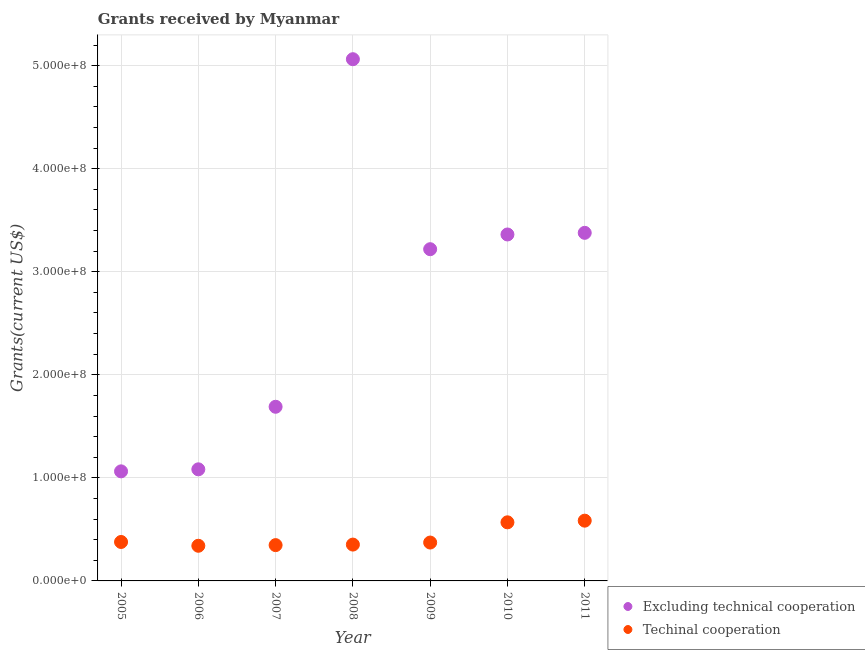How many different coloured dotlines are there?
Provide a succinct answer. 2. Is the number of dotlines equal to the number of legend labels?
Provide a succinct answer. Yes. What is the amount of grants received(including technical cooperation) in 2009?
Make the answer very short. 3.72e+07. Across all years, what is the maximum amount of grants received(including technical cooperation)?
Provide a succinct answer. 5.85e+07. Across all years, what is the minimum amount of grants received(including technical cooperation)?
Give a very brief answer. 3.41e+07. In which year was the amount of grants received(excluding technical cooperation) maximum?
Ensure brevity in your answer.  2008. What is the total amount of grants received(including technical cooperation) in the graph?
Ensure brevity in your answer.  2.94e+08. What is the difference between the amount of grants received(excluding technical cooperation) in 2009 and that in 2011?
Make the answer very short. -1.59e+07. What is the difference between the amount of grants received(including technical cooperation) in 2006 and the amount of grants received(excluding technical cooperation) in 2005?
Make the answer very short. -7.22e+07. What is the average amount of grants received(including technical cooperation) per year?
Offer a very short reply. 4.21e+07. In the year 2010, what is the difference between the amount of grants received(excluding technical cooperation) and amount of grants received(including technical cooperation)?
Give a very brief answer. 2.79e+08. In how many years, is the amount of grants received(including technical cooperation) greater than 160000000 US$?
Keep it short and to the point. 0. What is the ratio of the amount of grants received(excluding technical cooperation) in 2005 to that in 2006?
Your answer should be compact. 0.98. What is the difference between the highest and the second highest amount of grants received(excluding technical cooperation)?
Keep it short and to the point. 1.68e+08. What is the difference between the highest and the lowest amount of grants received(excluding technical cooperation)?
Offer a terse response. 4.00e+08. Is the sum of the amount of grants received(including technical cooperation) in 2010 and 2011 greater than the maximum amount of grants received(excluding technical cooperation) across all years?
Give a very brief answer. No. Does the amount of grants received(including technical cooperation) monotonically increase over the years?
Provide a short and direct response. No. Is the amount of grants received(excluding technical cooperation) strictly greater than the amount of grants received(including technical cooperation) over the years?
Keep it short and to the point. Yes. Is the amount of grants received(including technical cooperation) strictly less than the amount of grants received(excluding technical cooperation) over the years?
Your answer should be compact. Yes. How many dotlines are there?
Ensure brevity in your answer.  2. How many years are there in the graph?
Provide a succinct answer. 7. What is the difference between two consecutive major ticks on the Y-axis?
Make the answer very short. 1.00e+08. Does the graph contain any zero values?
Your answer should be compact. No. Does the graph contain grids?
Offer a very short reply. Yes. Where does the legend appear in the graph?
Provide a succinct answer. Bottom right. What is the title of the graph?
Your answer should be very brief. Grants received by Myanmar. Does "Non-resident workers" appear as one of the legend labels in the graph?
Your answer should be compact. No. What is the label or title of the X-axis?
Your answer should be compact. Year. What is the label or title of the Y-axis?
Provide a short and direct response. Grants(current US$). What is the Grants(current US$) in Excluding technical cooperation in 2005?
Make the answer very short. 1.06e+08. What is the Grants(current US$) in Techinal cooperation in 2005?
Your answer should be compact. 3.78e+07. What is the Grants(current US$) of Excluding technical cooperation in 2006?
Ensure brevity in your answer.  1.08e+08. What is the Grants(current US$) in Techinal cooperation in 2006?
Give a very brief answer. 3.41e+07. What is the Grants(current US$) in Excluding technical cooperation in 2007?
Your answer should be compact. 1.69e+08. What is the Grants(current US$) in Techinal cooperation in 2007?
Ensure brevity in your answer.  3.47e+07. What is the Grants(current US$) of Excluding technical cooperation in 2008?
Keep it short and to the point. 5.06e+08. What is the Grants(current US$) of Techinal cooperation in 2008?
Offer a terse response. 3.53e+07. What is the Grants(current US$) in Excluding technical cooperation in 2009?
Provide a short and direct response. 3.22e+08. What is the Grants(current US$) of Techinal cooperation in 2009?
Give a very brief answer. 3.72e+07. What is the Grants(current US$) of Excluding technical cooperation in 2010?
Offer a very short reply. 3.36e+08. What is the Grants(current US$) of Techinal cooperation in 2010?
Offer a very short reply. 5.69e+07. What is the Grants(current US$) in Excluding technical cooperation in 2011?
Your response must be concise. 3.38e+08. What is the Grants(current US$) of Techinal cooperation in 2011?
Your answer should be compact. 5.85e+07. Across all years, what is the maximum Grants(current US$) in Excluding technical cooperation?
Your response must be concise. 5.06e+08. Across all years, what is the maximum Grants(current US$) of Techinal cooperation?
Provide a short and direct response. 5.85e+07. Across all years, what is the minimum Grants(current US$) of Excluding technical cooperation?
Your response must be concise. 1.06e+08. Across all years, what is the minimum Grants(current US$) of Techinal cooperation?
Offer a very short reply. 3.41e+07. What is the total Grants(current US$) of Excluding technical cooperation in the graph?
Offer a terse response. 1.89e+09. What is the total Grants(current US$) of Techinal cooperation in the graph?
Offer a terse response. 2.94e+08. What is the difference between the Grants(current US$) in Excluding technical cooperation in 2005 and that in 2006?
Your response must be concise. -1.97e+06. What is the difference between the Grants(current US$) of Techinal cooperation in 2005 and that in 2006?
Your answer should be very brief. 3.68e+06. What is the difference between the Grants(current US$) in Excluding technical cooperation in 2005 and that in 2007?
Your response must be concise. -6.27e+07. What is the difference between the Grants(current US$) of Techinal cooperation in 2005 and that in 2007?
Provide a succinct answer. 3.05e+06. What is the difference between the Grants(current US$) in Excluding technical cooperation in 2005 and that in 2008?
Give a very brief answer. -4.00e+08. What is the difference between the Grants(current US$) of Techinal cooperation in 2005 and that in 2008?
Provide a succinct answer. 2.53e+06. What is the difference between the Grants(current US$) in Excluding technical cooperation in 2005 and that in 2009?
Your answer should be very brief. -2.16e+08. What is the difference between the Grants(current US$) in Excluding technical cooperation in 2005 and that in 2010?
Offer a terse response. -2.30e+08. What is the difference between the Grants(current US$) of Techinal cooperation in 2005 and that in 2010?
Your response must be concise. -1.91e+07. What is the difference between the Grants(current US$) of Excluding technical cooperation in 2005 and that in 2011?
Your answer should be compact. -2.31e+08. What is the difference between the Grants(current US$) in Techinal cooperation in 2005 and that in 2011?
Give a very brief answer. -2.07e+07. What is the difference between the Grants(current US$) in Excluding technical cooperation in 2006 and that in 2007?
Make the answer very short. -6.07e+07. What is the difference between the Grants(current US$) of Techinal cooperation in 2006 and that in 2007?
Provide a short and direct response. -6.30e+05. What is the difference between the Grants(current US$) in Excluding technical cooperation in 2006 and that in 2008?
Your answer should be compact. -3.98e+08. What is the difference between the Grants(current US$) of Techinal cooperation in 2006 and that in 2008?
Provide a short and direct response. -1.15e+06. What is the difference between the Grants(current US$) in Excluding technical cooperation in 2006 and that in 2009?
Your response must be concise. -2.14e+08. What is the difference between the Grants(current US$) of Techinal cooperation in 2006 and that in 2009?
Your answer should be very brief. -3.13e+06. What is the difference between the Grants(current US$) of Excluding technical cooperation in 2006 and that in 2010?
Provide a succinct answer. -2.28e+08. What is the difference between the Grants(current US$) of Techinal cooperation in 2006 and that in 2010?
Offer a very short reply. -2.28e+07. What is the difference between the Grants(current US$) of Excluding technical cooperation in 2006 and that in 2011?
Ensure brevity in your answer.  -2.29e+08. What is the difference between the Grants(current US$) in Techinal cooperation in 2006 and that in 2011?
Provide a succinct answer. -2.44e+07. What is the difference between the Grants(current US$) of Excluding technical cooperation in 2007 and that in 2008?
Offer a terse response. -3.37e+08. What is the difference between the Grants(current US$) of Techinal cooperation in 2007 and that in 2008?
Offer a very short reply. -5.20e+05. What is the difference between the Grants(current US$) in Excluding technical cooperation in 2007 and that in 2009?
Provide a short and direct response. -1.53e+08. What is the difference between the Grants(current US$) of Techinal cooperation in 2007 and that in 2009?
Provide a short and direct response. -2.50e+06. What is the difference between the Grants(current US$) in Excluding technical cooperation in 2007 and that in 2010?
Ensure brevity in your answer.  -1.67e+08. What is the difference between the Grants(current US$) in Techinal cooperation in 2007 and that in 2010?
Your answer should be very brief. -2.21e+07. What is the difference between the Grants(current US$) of Excluding technical cooperation in 2007 and that in 2011?
Your response must be concise. -1.69e+08. What is the difference between the Grants(current US$) of Techinal cooperation in 2007 and that in 2011?
Your response must be concise. -2.37e+07. What is the difference between the Grants(current US$) of Excluding technical cooperation in 2008 and that in 2009?
Offer a terse response. 1.84e+08. What is the difference between the Grants(current US$) of Techinal cooperation in 2008 and that in 2009?
Provide a succinct answer. -1.98e+06. What is the difference between the Grants(current US$) of Excluding technical cooperation in 2008 and that in 2010?
Offer a terse response. 1.70e+08. What is the difference between the Grants(current US$) in Techinal cooperation in 2008 and that in 2010?
Your answer should be compact. -2.16e+07. What is the difference between the Grants(current US$) of Excluding technical cooperation in 2008 and that in 2011?
Give a very brief answer. 1.68e+08. What is the difference between the Grants(current US$) of Techinal cooperation in 2008 and that in 2011?
Ensure brevity in your answer.  -2.32e+07. What is the difference between the Grants(current US$) in Excluding technical cooperation in 2009 and that in 2010?
Keep it short and to the point. -1.43e+07. What is the difference between the Grants(current US$) in Techinal cooperation in 2009 and that in 2010?
Ensure brevity in your answer.  -1.96e+07. What is the difference between the Grants(current US$) of Excluding technical cooperation in 2009 and that in 2011?
Give a very brief answer. -1.59e+07. What is the difference between the Grants(current US$) in Techinal cooperation in 2009 and that in 2011?
Your answer should be very brief. -2.12e+07. What is the difference between the Grants(current US$) in Excluding technical cooperation in 2010 and that in 2011?
Give a very brief answer. -1.59e+06. What is the difference between the Grants(current US$) in Techinal cooperation in 2010 and that in 2011?
Give a very brief answer. -1.61e+06. What is the difference between the Grants(current US$) of Excluding technical cooperation in 2005 and the Grants(current US$) of Techinal cooperation in 2006?
Your response must be concise. 7.22e+07. What is the difference between the Grants(current US$) of Excluding technical cooperation in 2005 and the Grants(current US$) of Techinal cooperation in 2007?
Ensure brevity in your answer.  7.16e+07. What is the difference between the Grants(current US$) in Excluding technical cooperation in 2005 and the Grants(current US$) in Techinal cooperation in 2008?
Ensure brevity in your answer.  7.11e+07. What is the difference between the Grants(current US$) of Excluding technical cooperation in 2005 and the Grants(current US$) of Techinal cooperation in 2009?
Offer a very short reply. 6.91e+07. What is the difference between the Grants(current US$) in Excluding technical cooperation in 2005 and the Grants(current US$) in Techinal cooperation in 2010?
Your answer should be very brief. 4.95e+07. What is the difference between the Grants(current US$) of Excluding technical cooperation in 2005 and the Grants(current US$) of Techinal cooperation in 2011?
Give a very brief answer. 4.78e+07. What is the difference between the Grants(current US$) in Excluding technical cooperation in 2006 and the Grants(current US$) in Techinal cooperation in 2007?
Give a very brief answer. 7.36e+07. What is the difference between the Grants(current US$) of Excluding technical cooperation in 2006 and the Grants(current US$) of Techinal cooperation in 2008?
Give a very brief answer. 7.30e+07. What is the difference between the Grants(current US$) of Excluding technical cooperation in 2006 and the Grants(current US$) of Techinal cooperation in 2009?
Give a very brief answer. 7.10e+07. What is the difference between the Grants(current US$) in Excluding technical cooperation in 2006 and the Grants(current US$) in Techinal cooperation in 2010?
Provide a succinct answer. 5.14e+07. What is the difference between the Grants(current US$) in Excluding technical cooperation in 2006 and the Grants(current US$) in Techinal cooperation in 2011?
Offer a terse response. 4.98e+07. What is the difference between the Grants(current US$) in Excluding technical cooperation in 2007 and the Grants(current US$) in Techinal cooperation in 2008?
Keep it short and to the point. 1.34e+08. What is the difference between the Grants(current US$) of Excluding technical cooperation in 2007 and the Grants(current US$) of Techinal cooperation in 2009?
Provide a succinct answer. 1.32e+08. What is the difference between the Grants(current US$) in Excluding technical cooperation in 2007 and the Grants(current US$) in Techinal cooperation in 2010?
Your answer should be very brief. 1.12e+08. What is the difference between the Grants(current US$) of Excluding technical cooperation in 2007 and the Grants(current US$) of Techinal cooperation in 2011?
Your answer should be very brief. 1.11e+08. What is the difference between the Grants(current US$) in Excluding technical cooperation in 2008 and the Grants(current US$) in Techinal cooperation in 2009?
Ensure brevity in your answer.  4.69e+08. What is the difference between the Grants(current US$) in Excluding technical cooperation in 2008 and the Grants(current US$) in Techinal cooperation in 2010?
Give a very brief answer. 4.49e+08. What is the difference between the Grants(current US$) of Excluding technical cooperation in 2008 and the Grants(current US$) of Techinal cooperation in 2011?
Keep it short and to the point. 4.48e+08. What is the difference between the Grants(current US$) in Excluding technical cooperation in 2009 and the Grants(current US$) in Techinal cooperation in 2010?
Your answer should be very brief. 2.65e+08. What is the difference between the Grants(current US$) of Excluding technical cooperation in 2009 and the Grants(current US$) of Techinal cooperation in 2011?
Your answer should be compact. 2.63e+08. What is the difference between the Grants(current US$) in Excluding technical cooperation in 2010 and the Grants(current US$) in Techinal cooperation in 2011?
Your response must be concise. 2.78e+08. What is the average Grants(current US$) in Excluding technical cooperation per year?
Provide a succinct answer. 2.69e+08. What is the average Grants(current US$) in Techinal cooperation per year?
Provide a short and direct response. 4.21e+07. In the year 2005, what is the difference between the Grants(current US$) of Excluding technical cooperation and Grants(current US$) of Techinal cooperation?
Provide a succinct answer. 6.85e+07. In the year 2006, what is the difference between the Grants(current US$) in Excluding technical cooperation and Grants(current US$) in Techinal cooperation?
Provide a short and direct response. 7.42e+07. In the year 2007, what is the difference between the Grants(current US$) of Excluding technical cooperation and Grants(current US$) of Techinal cooperation?
Your answer should be very brief. 1.34e+08. In the year 2008, what is the difference between the Grants(current US$) in Excluding technical cooperation and Grants(current US$) in Techinal cooperation?
Ensure brevity in your answer.  4.71e+08. In the year 2009, what is the difference between the Grants(current US$) of Excluding technical cooperation and Grants(current US$) of Techinal cooperation?
Ensure brevity in your answer.  2.85e+08. In the year 2010, what is the difference between the Grants(current US$) in Excluding technical cooperation and Grants(current US$) in Techinal cooperation?
Make the answer very short. 2.79e+08. In the year 2011, what is the difference between the Grants(current US$) of Excluding technical cooperation and Grants(current US$) of Techinal cooperation?
Offer a very short reply. 2.79e+08. What is the ratio of the Grants(current US$) in Excluding technical cooperation in 2005 to that in 2006?
Your response must be concise. 0.98. What is the ratio of the Grants(current US$) in Techinal cooperation in 2005 to that in 2006?
Keep it short and to the point. 1.11. What is the ratio of the Grants(current US$) in Excluding technical cooperation in 2005 to that in 2007?
Offer a very short reply. 0.63. What is the ratio of the Grants(current US$) of Techinal cooperation in 2005 to that in 2007?
Ensure brevity in your answer.  1.09. What is the ratio of the Grants(current US$) of Excluding technical cooperation in 2005 to that in 2008?
Offer a very short reply. 0.21. What is the ratio of the Grants(current US$) of Techinal cooperation in 2005 to that in 2008?
Offer a terse response. 1.07. What is the ratio of the Grants(current US$) in Excluding technical cooperation in 2005 to that in 2009?
Your answer should be very brief. 0.33. What is the ratio of the Grants(current US$) of Techinal cooperation in 2005 to that in 2009?
Offer a very short reply. 1.01. What is the ratio of the Grants(current US$) of Excluding technical cooperation in 2005 to that in 2010?
Make the answer very short. 0.32. What is the ratio of the Grants(current US$) in Techinal cooperation in 2005 to that in 2010?
Make the answer very short. 0.66. What is the ratio of the Grants(current US$) of Excluding technical cooperation in 2005 to that in 2011?
Make the answer very short. 0.31. What is the ratio of the Grants(current US$) in Techinal cooperation in 2005 to that in 2011?
Your response must be concise. 0.65. What is the ratio of the Grants(current US$) of Excluding technical cooperation in 2006 to that in 2007?
Give a very brief answer. 0.64. What is the ratio of the Grants(current US$) in Techinal cooperation in 2006 to that in 2007?
Offer a terse response. 0.98. What is the ratio of the Grants(current US$) of Excluding technical cooperation in 2006 to that in 2008?
Your answer should be very brief. 0.21. What is the ratio of the Grants(current US$) in Techinal cooperation in 2006 to that in 2008?
Your answer should be compact. 0.97. What is the ratio of the Grants(current US$) in Excluding technical cooperation in 2006 to that in 2009?
Your answer should be compact. 0.34. What is the ratio of the Grants(current US$) of Techinal cooperation in 2006 to that in 2009?
Ensure brevity in your answer.  0.92. What is the ratio of the Grants(current US$) in Excluding technical cooperation in 2006 to that in 2010?
Make the answer very short. 0.32. What is the ratio of the Grants(current US$) of Techinal cooperation in 2006 to that in 2010?
Your response must be concise. 0.6. What is the ratio of the Grants(current US$) of Excluding technical cooperation in 2006 to that in 2011?
Offer a terse response. 0.32. What is the ratio of the Grants(current US$) of Techinal cooperation in 2006 to that in 2011?
Your answer should be compact. 0.58. What is the ratio of the Grants(current US$) in Excluding technical cooperation in 2007 to that in 2008?
Keep it short and to the point. 0.33. What is the ratio of the Grants(current US$) of Excluding technical cooperation in 2007 to that in 2009?
Keep it short and to the point. 0.53. What is the ratio of the Grants(current US$) in Techinal cooperation in 2007 to that in 2009?
Ensure brevity in your answer.  0.93. What is the ratio of the Grants(current US$) of Excluding technical cooperation in 2007 to that in 2010?
Your response must be concise. 0.5. What is the ratio of the Grants(current US$) of Techinal cooperation in 2007 to that in 2010?
Your answer should be very brief. 0.61. What is the ratio of the Grants(current US$) of Excluding technical cooperation in 2007 to that in 2011?
Your answer should be compact. 0.5. What is the ratio of the Grants(current US$) in Techinal cooperation in 2007 to that in 2011?
Your answer should be compact. 0.59. What is the ratio of the Grants(current US$) in Excluding technical cooperation in 2008 to that in 2009?
Offer a very short reply. 1.57. What is the ratio of the Grants(current US$) in Techinal cooperation in 2008 to that in 2009?
Ensure brevity in your answer.  0.95. What is the ratio of the Grants(current US$) in Excluding technical cooperation in 2008 to that in 2010?
Your answer should be very brief. 1.51. What is the ratio of the Grants(current US$) in Techinal cooperation in 2008 to that in 2010?
Provide a succinct answer. 0.62. What is the ratio of the Grants(current US$) in Excluding technical cooperation in 2008 to that in 2011?
Provide a short and direct response. 1.5. What is the ratio of the Grants(current US$) of Techinal cooperation in 2008 to that in 2011?
Keep it short and to the point. 0.6. What is the ratio of the Grants(current US$) in Excluding technical cooperation in 2009 to that in 2010?
Give a very brief answer. 0.96. What is the ratio of the Grants(current US$) of Techinal cooperation in 2009 to that in 2010?
Your response must be concise. 0.65. What is the ratio of the Grants(current US$) in Excluding technical cooperation in 2009 to that in 2011?
Provide a succinct answer. 0.95. What is the ratio of the Grants(current US$) of Techinal cooperation in 2009 to that in 2011?
Make the answer very short. 0.64. What is the ratio of the Grants(current US$) of Techinal cooperation in 2010 to that in 2011?
Give a very brief answer. 0.97. What is the difference between the highest and the second highest Grants(current US$) in Excluding technical cooperation?
Offer a terse response. 1.68e+08. What is the difference between the highest and the second highest Grants(current US$) of Techinal cooperation?
Make the answer very short. 1.61e+06. What is the difference between the highest and the lowest Grants(current US$) of Excluding technical cooperation?
Your response must be concise. 4.00e+08. What is the difference between the highest and the lowest Grants(current US$) of Techinal cooperation?
Your response must be concise. 2.44e+07. 